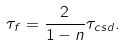<formula> <loc_0><loc_0><loc_500><loc_500>\tau _ { f } = \frac { 2 } { 1 - n } \tau _ { c s d } .</formula> 